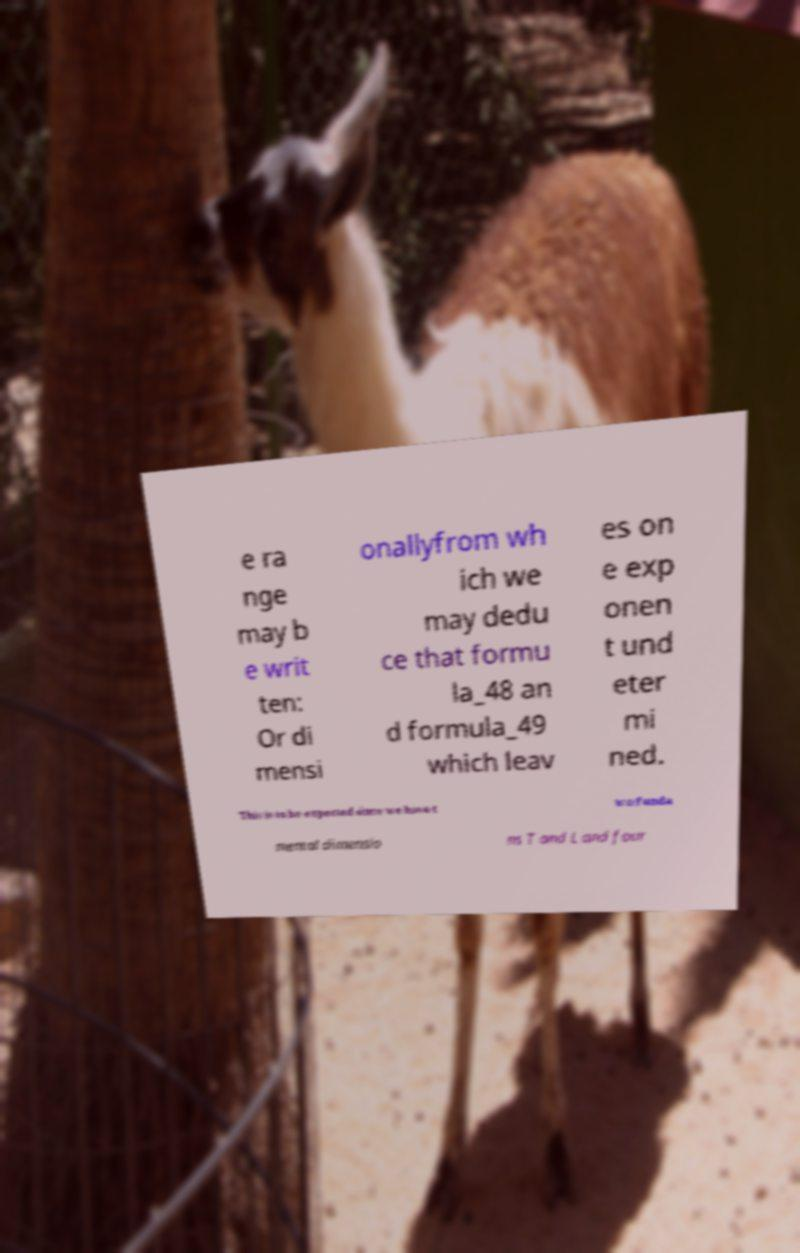There's text embedded in this image that I need extracted. Can you transcribe it verbatim? e ra nge may b e writ ten: Or di mensi onallyfrom wh ich we may dedu ce that formu la_48 an d formula_49 which leav es on e exp onen t und eter mi ned. This is to be expected since we have t wo funda mental dimensio ns T and L and four 